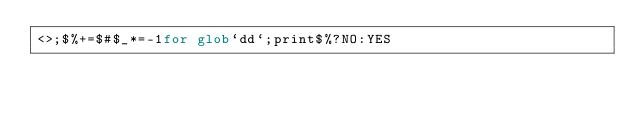<code> <loc_0><loc_0><loc_500><loc_500><_Perl_><>;$%+=$#$_*=-1for glob`dd`;print$%?NO:YES</code> 